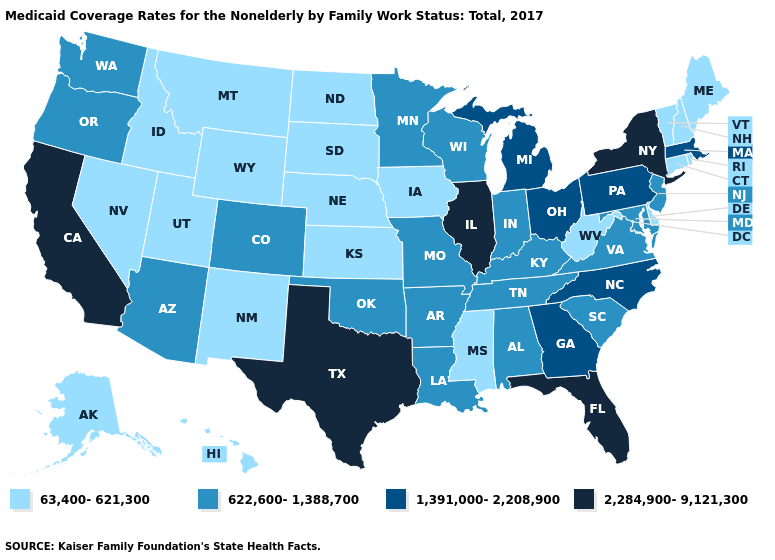Among the states that border Arkansas , which have the lowest value?
Be succinct. Mississippi. Among the states that border Florida , does Alabama have the highest value?
Answer briefly. No. What is the value of Tennessee?
Write a very short answer. 622,600-1,388,700. What is the highest value in states that border Washington?
Be succinct. 622,600-1,388,700. What is the value of Massachusetts?
Quick response, please. 1,391,000-2,208,900. What is the value of Iowa?
Quick response, please. 63,400-621,300. What is the value of Virginia?
Keep it brief. 622,600-1,388,700. Name the states that have a value in the range 1,391,000-2,208,900?
Give a very brief answer. Georgia, Massachusetts, Michigan, North Carolina, Ohio, Pennsylvania. How many symbols are there in the legend?
Concise answer only. 4. What is the value of Maryland?
Quick response, please. 622,600-1,388,700. Which states have the lowest value in the MidWest?
Write a very short answer. Iowa, Kansas, Nebraska, North Dakota, South Dakota. Name the states that have a value in the range 63,400-621,300?
Answer briefly. Alaska, Connecticut, Delaware, Hawaii, Idaho, Iowa, Kansas, Maine, Mississippi, Montana, Nebraska, Nevada, New Hampshire, New Mexico, North Dakota, Rhode Island, South Dakota, Utah, Vermont, West Virginia, Wyoming. What is the highest value in states that border North Dakota?
Be succinct. 622,600-1,388,700. Which states have the lowest value in the South?
Answer briefly. Delaware, Mississippi, West Virginia. Does the first symbol in the legend represent the smallest category?
Keep it brief. Yes. 